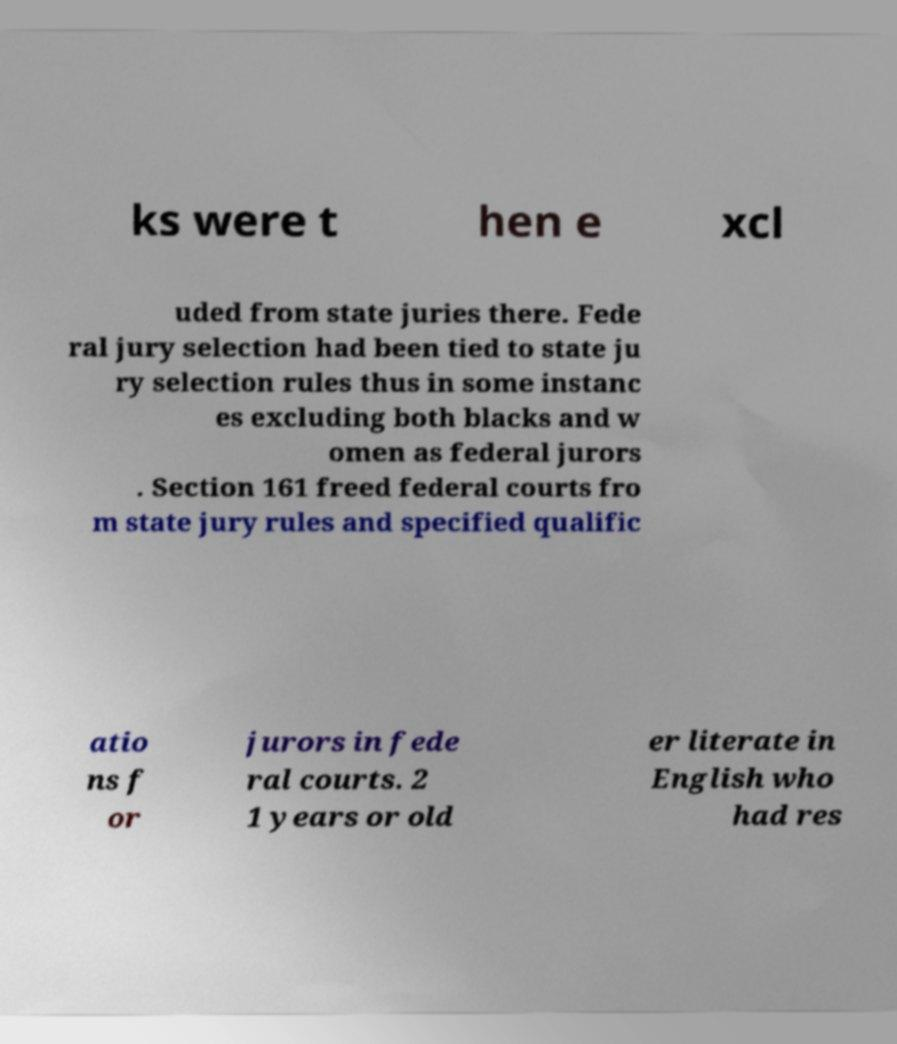Could you extract and type out the text from this image? ks were t hen e xcl uded from state juries there. Fede ral jury selection had been tied to state ju ry selection rules thus in some instanc es excluding both blacks and w omen as federal jurors . Section 161 freed federal courts fro m state jury rules and specified qualific atio ns f or jurors in fede ral courts. 2 1 years or old er literate in English who had res 